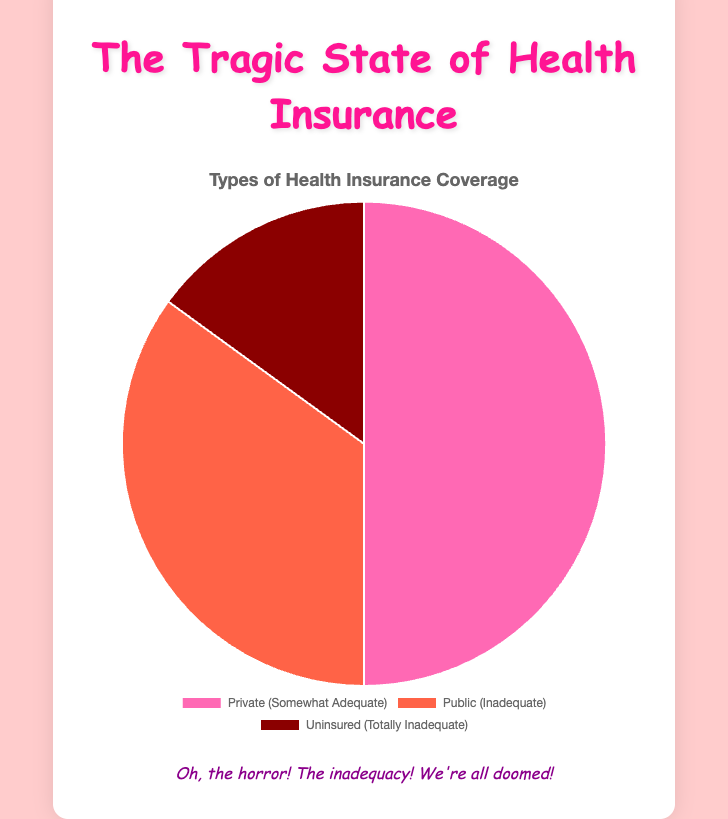What percentage of health insurance coverage is considered inadequate? Add the percentage of Public (35%) and Uninsured (15%) as both are perceived as inadequate
Answer: 50% Which type of health insurance has the highest perceived inadequacy? Compare the perceived adequacy of Public (Inadequate) and Uninsured (Totally Inadequate)
Answer: Uninsured How much greater is the percentage of Private insurance compared to Uninsured? Subtract the percentage of Uninsured (15%) from Private (50%)
Answer: 35% What is the combined percentage of Private and Public insurance coverage? Add the percentages of Private (50%) and Public (35%) insurance
Answer: 85% What color is used to represent Public insurance coverage in the chart? Look at the color associated with Public insurance, which is visually represented
Answer: Tomato red Which type of health insurance has the lowest percentage of coverage? Identify the insurance type with the smallest percentage, which is Uninsured (15%)
Answer: Uninsured What fraction of the total insurance coverage does Public insurance represent? Divide the percentage of Public insurance (35%) by the total (100%) and simplify if possible
Answer: 35/100 or 7/20 